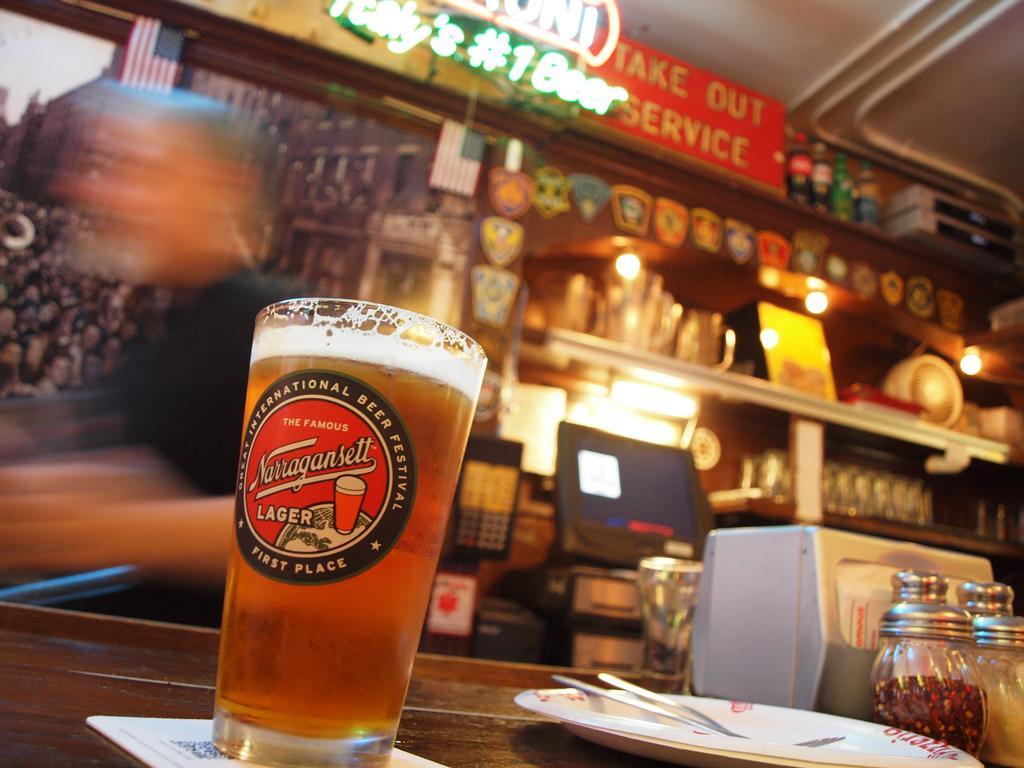Could you give a brief overview of what you see in this image? In the picture we can see a glass with the label on it and a drink in it, we can see a plate, fork, jars and tissue box are placed on the wooden table. The background of the image is slightly blurred, where we can see some objects, LED board, bottles and a person who is completely blurred. 